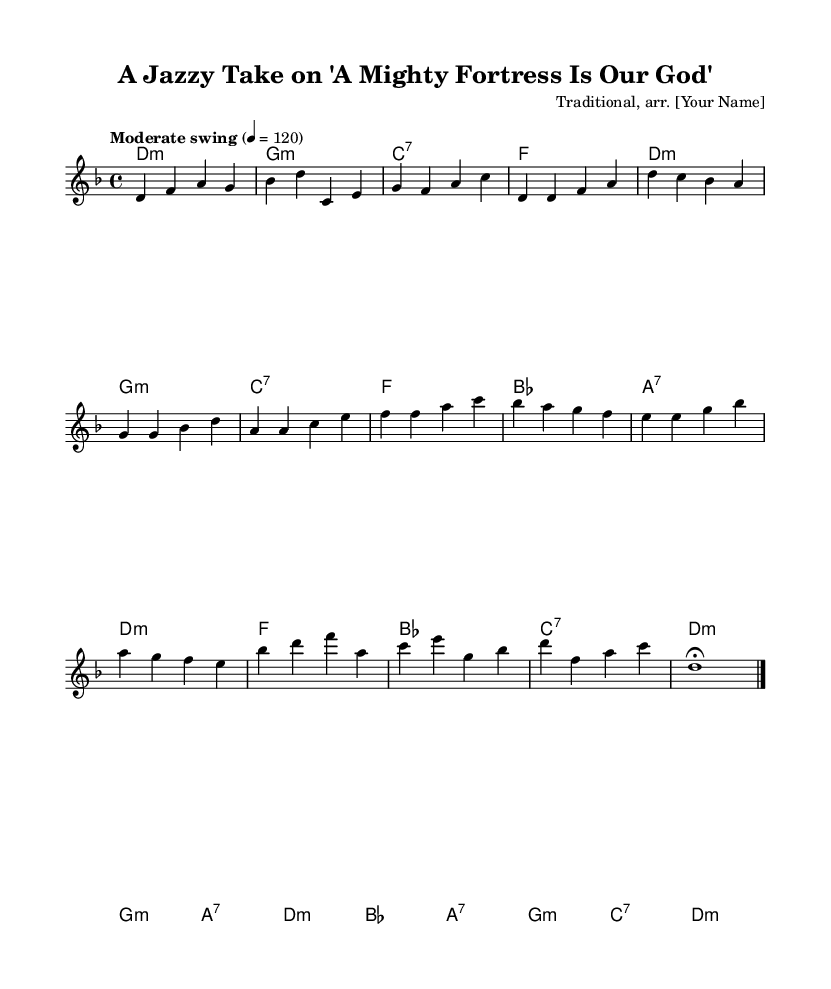What is the key signature of this music? The key signature indicates that the music is in D minor, identifiable by the one flat, B flat, shown before the staff.
Answer: D minor What is the time signature of this piece? The time signature is indicated as 4/4, meaning there are four beats in a measure. This can be found at the beginning of the piece.
Answer: 4/4 What is the tempo marking provided? The tempo marking provided is "Moderate swing," which suggests a laid-back swing feel, as indicated in the tempo text at the beginning.
Answer: Moderate swing How many measures are in the verse section? To find the answer, we need to count the measures in the verse section; there are four measures in the verse section. Each measure is separated by vertical lines.
Answer: Four What type of chords appear in the bridge section? The chords in the bridge section are bes major, a seventh, g minor, and c seventh, which can be identified in the chord lines below the melody.
Answer: bes, a, g, c Which jazz technique is applied in the arrangement? The arrangement uses swing rhythm, as indicated by the tempo marking and the style of the melody, which incorporates syncopated rhythms typical of jazz.
Answer: Swing What is the ending note of the melody? The ending note, marked with a fermata, is D, as shown at the end of the melody line where it holds for an extended duration.
Answer: D 